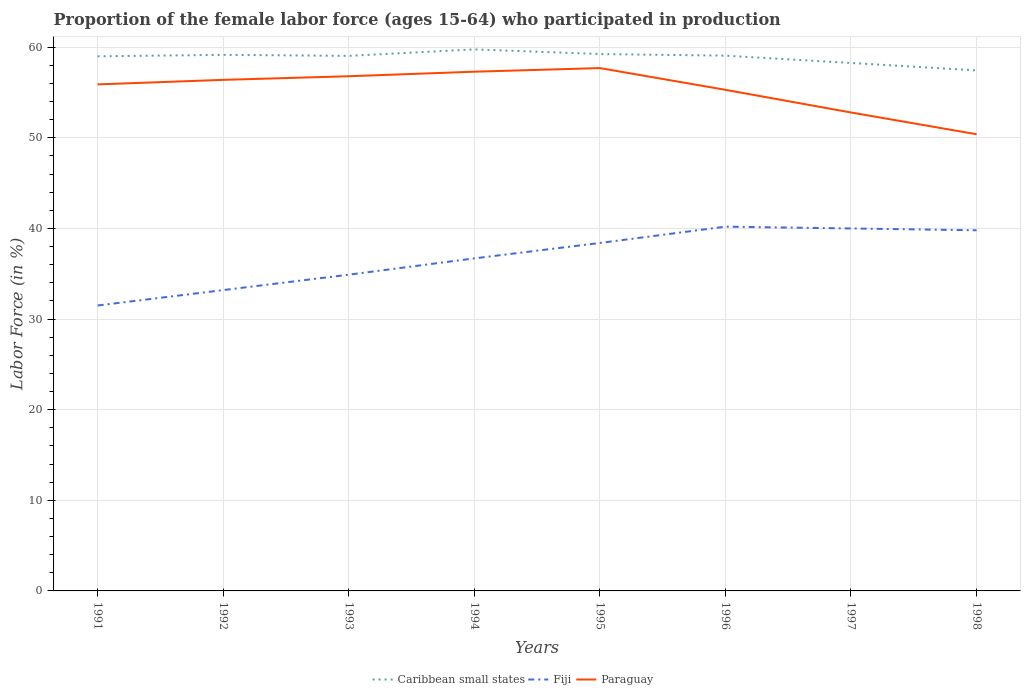Across all years, what is the maximum proportion of the female labor force who participated in production in Caribbean small states?
Your answer should be very brief. 57.44. What is the total proportion of the female labor force who participated in production in Paraguay in the graph?
Make the answer very short. 2.4. What is the difference between the highest and the second highest proportion of the female labor force who participated in production in Fiji?
Give a very brief answer. 8.7. What is the difference between the highest and the lowest proportion of the female labor force who participated in production in Fiji?
Give a very brief answer. 4. How many lines are there?
Make the answer very short. 3. What is the difference between two consecutive major ticks on the Y-axis?
Give a very brief answer. 10. Are the values on the major ticks of Y-axis written in scientific E-notation?
Offer a terse response. No. Does the graph contain any zero values?
Ensure brevity in your answer.  No. Does the graph contain grids?
Provide a short and direct response. Yes. How many legend labels are there?
Your answer should be very brief. 3. What is the title of the graph?
Make the answer very short. Proportion of the female labor force (ages 15-64) who participated in production. Does "Faeroe Islands" appear as one of the legend labels in the graph?
Your response must be concise. No. What is the label or title of the X-axis?
Give a very brief answer. Years. What is the Labor Force (in %) in Caribbean small states in 1991?
Keep it short and to the point. 59. What is the Labor Force (in %) in Fiji in 1991?
Give a very brief answer. 31.5. What is the Labor Force (in %) of Paraguay in 1991?
Offer a terse response. 55.9. What is the Labor Force (in %) of Caribbean small states in 1992?
Your response must be concise. 59.16. What is the Labor Force (in %) in Fiji in 1992?
Provide a succinct answer. 33.2. What is the Labor Force (in %) of Paraguay in 1992?
Your answer should be very brief. 56.4. What is the Labor Force (in %) of Caribbean small states in 1993?
Your response must be concise. 59.05. What is the Labor Force (in %) in Fiji in 1993?
Provide a succinct answer. 34.9. What is the Labor Force (in %) of Paraguay in 1993?
Keep it short and to the point. 56.8. What is the Labor Force (in %) in Caribbean small states in 1994?
Keep it short and to the point. 59.76. What is the Labor Force (in %) in Fiji in 1994?
Give a very brief answer. 36.7. What is the Labor Force (in %) of Paraguay in 1994?
Offer a very short reply. 57.3. What is the Labor Force (in %) of Caribbean small states in 1995?
Provide a short and direct response. 59.25. What is the Labor Force (in %) of Fiji in 1995?
Your answer should be very brief. 38.4. What is the Labor Force (in %) in Paraguay in 1995?
Give a very brief answer. 57.7. What is the Labor Force (in %) in Caribbean small states in 1996?
Ensure brevity in your answer.  59.07. What is the Labor Force (in %) in Fiji in 1996?
Your answer should be very brief. 40.2. What is the Labor Force (in %) of Paraguay in 1996?
Provide a succinct answer. 55.3. What is the Labor Force (in %) of Caribbean small states in 1997?
Make the answer very short. 58.26. What is the Labor Force (in %) in Paraguay in 1997?
Provide a short and direct response. 52.8. What is the Labor Force (in %) of Caribbean small states in 1998?
Keep it short and to the point. 57.44. What is the Labor Force (in %) in Fiji in 1998?
Your response must be concise. 39.8. What is the Labor Force (in %) of Paraguay in 1998?
Your answer should be compact. 50.4. Across all years, what is the maximum Labor Force (in %) in Caribbean small states?
Your response must be concise. 59.76. Across all years, what is the maximum Labor Force (in %) of Fiji?
Ensure brevity in your answer.  40.2. Across all years, what is the maximum Labor Force (in %) of Paraguay?
Give a very brief answer. 57.7. Across all years, what is the minimum Labor Force (in %) of Caribbean small states?
Provide a succinct answer. 57.44. Across all years, what is the minimum Labor Force (in %) in Fiji?
Provide a short and direct response. 31.5. Across all years, what is the minimum Labor Force (in %) of Paraguay?
Your answer should be compact. 50.4. What is the total Labor Force (in %) of Caribbean small states in the graph?
Offer a very short reply. 471. What is the total Labor Force (in %) in Fiji in the graph?
Offer a terse response. 294.7. What is the total Labor Force (in %) in Paraguay in the graph?
Your answer should be compact. 442.6. What is the difference between the Labor Force (in %) of Caribbean small states in 1991 and that in 1992?
Your answer should be compact. -0.16. What is the difference between the Labor Force (in %) in Fiji in 1991 and that in 1992?
Your answer should be compact. -1.7. What is the difference between the Labor Force (in %) of Paraguay in 1991 and that in 1992?
Keep it short and to the point. -0.5. What is the difference between the Labor Force (in %) in Caribbean small states in 1991 and that in 1993?
Your answer should be very brief. -0.05. What is the difference between the Labor Force (in %) in Caribbean small states in 1991 and that in 1994?
Offer a very short reply. -0.76. What is the difference between the Labor Force (in %) in Fiji in 1991 and that in 1994?
Your answer should be compact. -5.2. What is the difference between the Labor Force (in %) in Paraguay in 1991 and that in 1994?
Your answer should be compact. -1.4. What is the difference between the Labor Force (in %) in Caribbean small states in 1991 and that in 1995?
Provide a short and direct response. -0.25. What is the difference between the Labor Force (in %) in Caribbean small states in 1991 and that in 1996?
Keep it short and to the point. -0.07. What is the difference between the Labor Force (in %) of Paraguay in 1991 and that in 1996?
Provide a succinct answer. 0.6. What is the difference between the Labor Force (in %) of Caribbean small states in 1991 and that in 1997?
Provide a succinct answer. 0.74. What is the difference between the Labor Force (in %) of Fiji in 1991 and that in 1997?
Provide a succinct answer. -8.5. What is the difference between the Labor Force (in %) of Caribbean small states in 1991 and that in 1998?
Keep it short and to the point. 1.56. What is the difference between the Labor Force (in %) of Fiji in 1991 and that in 1998?
Ensure brevity in your answer.  -8.3. What is the difference between the Labor Force (in %) in Paraguay in 1991 and that in 1998?
Your response must be concise. 5.5. What is the difference between the Labor Force (in %) of Caribbean small states in 1992 and that in 1993?
Keep it short and to the point. 0.11. What is the difference between the Labor Force (in %) in Paraguay in 1992 and that in 1993?
Your answer should be very brief. -0.4. What is the difference between the Labor Force (in %) in Caribbean small states in 1992 and that in 1994?
Keep it short and to the point. -0.6. What is the difference between the Labor Force (in %) of Fiji in 1992 and that in 1994?
Offer a very short reply. -3.5. What is the difference between the Labor Force (in %) of Paraguay in 1992 and that in 1994?
Ensure brevity in your answer.  -0.9. What is the difference between the Labor Force (in %) of Caribbean small states in 1992 and that in 1995?
Your response must be concise. -0.09. What is the difference between the Labor Force (in %) in Caribbean small states in 1992 and that in 1996?
Give a very brief answer. 0.09. What is the difference between the Labor Force (in %) in Fiji in 1992 and that in 1996?
Keep it short and to the point. -7. What is the difference between the Labor Force (in %) of Caribbean small states in 1992 and that in 1997?
Offer a terse response. 0.9. What is the difference between the Labor Force (in %) in Fiji in 1992 and that in 1997?
Ensure brevity in your answer.  -6.8. What is the difference between the Labor Force (in %) in Paraguay in 1992 and that in 1997?
Your answer should be compact. 3.6. What is the difference between the Labor Force (in %) of Caribbean small states in 1992 and that in 1998?
Provide a succinct answer. 1.72. What is the difference between the Labor Force (in %) in Caribbean small states in 1993 and that in 1994?
Your answer should be very brief. -0.72. What is the difference between the Labor Force (in %) of Paraguay in 1993 and that in 1994?
Offer a very short reply. -0.5. What is the difference between the Labor Force (in %) in Caribbean small states in 1993 and that in 1995?
Give a very brief answer. -0.2. What is the difference between the Labor Force (in %) in Fiji in 1993 and that in 1995?
Provide a succinct answer. -3.5. What is the difference between the Labor Force (in %) in Caribbean small states in 1993 and that in 1996?
Your response must be concise. -0.02. What is the difference between the Labor Force (in %) in Fiji in 1993 and that in 1996?
Make the answer very short. -5.3. What is the difference between the Labor Force (in %) of Caribbean small states in 1993 and that in 1997?
Make the answer very short. 0.78. What is the difference between the Labor Force (in %) of Fiji in 1993 and that in 1997?
Make the answer very short. -5.1. What is the difference between the Labor Force (in %) of Paraguay in 1993 and that in 1997?
Your answer should be compact. 4. What is the difference between the Labor Force (in %) in Caribbean small states in 1993 and that in 1998?
Offer a very short reply. 1.61. What is the difference between the Labor Force (in %) of Fiji in 1993 and that in 1998?
Your answer should be compact. -4.9. What is the difference between the Labor Force (in %) of Caribbean small states in 1994 and that in 1995?
Keep it short and to the point. 0.51. What is the difference between the Labor Force (in %) of Fiji in 1994 and that in 1995?
Your answer should be very brief. -1.7. What is the difference between the Labor Force (in %) in Paraguay in 1994 and that in 1995?
Ensure brevity in your answer.  -0.4. What is the difference between the Labor Force (in %) in Caribbean small states in 1994 and that in 1996?
Offer a terse response. 0.69. What is the difference between the Labor Force (in %) of Caribbean small states in 1994 and that in 1997?
Ensure brevity in your answer.  1.5. What is the difference between the Labor Force (in %) of Paraguay in 1994 and that in 1997?
Give a very brief answer. 4.5. What is the difference between the Labor Force (in %) of Caribbean small states in 1994 and that in 1998?
Your answer should be compact. 2.32. What is the difference between the Labor Force (in %) in Fiji in 1994 and that in 1998?
Your response must be concise. -3.1. What is the difference between the Labor Force (in %) of Caribbean small states in 1995 and that in 1996?
Provide a short and direct response. 0.18. What is the difference between the Labor Force (in %) in Fiji in 1995 and that in 1996?
Offer a terse response. -1.8. What is the difference between the Labor Force (in %) in Paraguay in 1995 and that in 1996?
Offer a very short reply. 2.4. What is the difference between the Labor Force (in %) in Caribbean small states in 1995 and that in 1997?
Give a very brief answer. 0.99. What is the difference between the Labor Force (in %) in Paraguay in 1995 and that in 1997?
Keep it short and to the point. 4.9. What is the difference between the Labor Force (in %) of Caribbean small states in 1995 and that in 1998?
Your answer should be very brief. 1.81. What is the difference between the Labor Force (in %) of Fiji in 1995 and that in 1998?
Provide a succinct answer. -1.4. What is the difference between the Labor Force (in %) in Caribbean small states in 1996 and that in 1997?
Your response must be concise. 0.81. What is the difference between the Labor Force (in %) in Fiji in 1996 and that in 1997?
Provide a succinct answer. 0.2. What is the difference between the Labor Force (in %) of Paraguay in 1996 and that in 1997?
Your answer should be compact. 2.5. What is the difference between the Labor Force (in %) in Caribbean small states in 1996 and that in 1998?
Ensure brevity in your answer.  1.63. What is the difference between the Labor Force (in %) of Fiji in 1996 and that in 1998?
Offer a very short reply. 0.4. What is the difference between the Labor Force (in %) in Caribbean small states in 1997 and that in 1998?
Give a very brief answer. 0.82. What is the difference between the Labor Force (in %) of Caribbean small states in 1991 and the Labor Force (in %) of Fiji in 1992?
Give a very brief answer. 25.8. What is the difference between the Labor Force (in %) of Caribbean small states in 1991 and the Labor Force (in %) of Paraguay in 1992?
Offer a very short reply. 2.6. What is the difference between the Labor Force (in %) of Fiji in 1991 and the Labor Force (in %) of Paraguay in 1992?
Offer a very short reply. -24.9. What is the difference between the Labor Force (in %) in Caribbean small states in 1991 and the Labor Force (in %) in Fiji in 1993?
Provide a short and direct response. 24.1. What is the difference between the Labor Force (in %) in Caribbean small states in 1991 and the Labor Force (in %) in Paraguay in 1993?
Ensure brevity in your answer.  2.2. What is the difference between the Labor Force (in %) in Fiji in 1991 and the Labor Force (in %) in Paraguay in 1993?
Your response must be concise. -25.3. What is the difference between the Labor Force (in %) in Caribbean small states in 1991 and the Labor Force (in %) in Fiji in 1994?
Ensure brevity in your answer.  22.3. What is the difference between the Labor Force (in %) in Caribbean small states in 1991 and the Labor Force (in %) in Paraguay in 1994?
Your response must be concise. 1.7. What is the difference between the Labor Force (in %) in Fiji in 1991 and the Labor Force (in %) in Paraguay in 1994?
Offer a terse response. -25.8. What is the difference between the Labor Force (in %) in Caribbean small states in 1991 and the Labor Force (in %) in Fiji in 1995?
Offer a very short reply. 20.6. What is the difference between the Labor Force (in %) of Caribbean small states in 1991 and the Labor Force (in %) of Paraguay in 1995?
Give a very brief answer. 1.3. What is the difference between the Labor Force (in %) of Fiji in 1991 and the Labor Force (in %) of Paraguay in 1995?
Provide a short and direct response. -26.2. What is the difference between the Labor Force (in %) of Caribbean small states in 1991 and the Labor Force (in %) of Fiji in 1996?
Your response must be concise. 18.8. What is the difference between the Labor Force (in %) in Caribbean small states in 1991 and the Labor Force (in %) in Paraguay in 1996?
Provide a short and direct response. 3.7. What is the difference between the Labor Force (in %) of Fiji in 1991 and the Labor Force (in %) of Paraguay in 1996?
Give a very brief answer. -23.8. What is the difference between the Labor Force (in %) in Caribbean small states in 1991 and the Labor Force (in %) in Fiji in 1997?
Give a very brief answer. 19. What is the difference between the Labor Force (in %) in Caribbean small states in 1991 and the Labor Force (in %) in Paraguay in 1997?
Provide a short and direct response. 6.2. What is the difference between the Labor Force (in %) of Fiji in 1991 and the Labor Force (in %) of Paraguay in 1997?
Offer a terse response. -21.3. What is the difference between the Labor Force (in %) of Caribbean small states in 1991 and the Labor Force (in %) of Fiji in 1998?
Provide a short and direct response. 19.2. What is the difference between the Labor Force (in %) in Caribbean small states in 1991 and the Labor Force (in %) in Paraguay in 1998?
Keep it short and to the point. 8.6. What is the difference between the Labor Force (in %) in Fiji in 1991 and the Labor Force (in %) in Paraguay in 1998?
Offer a very short reply. -18.9. What is the difference between the Labor Force (in %) of Caribbean small states in 1992 and the Labor Force (in %) of Fiji in 1993?
Your answer should be very brief. 24.26. What is the difference between the Labor Force (in %) in Caribbean small states in 1992 and the Labor Force (in %) in Paraguay in 1993?
Make the answer very short. 2.36. What is the difference between the Labor Force (in %) in Fiji in 1992 and the Labor Force (in %) in Paraguay in 1993?
Your answer should be very brief. -23.6. What is the difference between the Labor Force (in %) of Caribbean small states in 1992 and the Labor Force (in %) of Fiji in 1994?
Make the answer very short. 22.46. What is the difference between the Labor Force (in %) in Caribbean small states in 1992 and the Labor Force (in %) in Paraguay in 1994?
Provide a succinct answer. 1.86. What is the difference between the Labor Force (in %) of Fiji in 1992 and the Labor Force (in %) of Paraguay in 1994?
Provide a succinct answer. -24.1. What is the difference between the Labor Force (in %) in Caribbean small states in 1992 and the Labor Force (in %) in Fiji in 1995?
Provide a succinct answer. 20.76. What is the difference between the Labor Force (in %) of Caribbean small states in 1992 and the Labor Force (in %) of Paraguay in 1995?
Your response must be concise. 1.46. What is the difference between the Labor Force (in %) of Fiji in 1992 and the Labor Force (in %) of Paraguay in 1995?
Offer a very short reply. -24.5. What is the difference between the Labor Force (in %) of Caribbean small states in 1992 and the Labor Force (in %) of Fiji in 1996?
Your answer should be very brief. 18.96. What is the difference between the Labor Force (in %) of Caribbean small states in 1992 and the Labor Force (in %) of Paraguay in 1996?
Your answer should be compact. 3.86. What is the difference between the Labor Force (in %) of Fiji in 1992 and the Labor Force (in %) of Paraguay in 1996?
Offer a very short reply. -22.1. What is the difference between the Labor Force (in %) of Caribbean small states in 1992 and the Labor Force (in %) of Fiji in 1997?
Offer a very short reply. 19.16. What is the difference between the Labor Force (in %) in Caribbean small states in 1992 and the Labor Force (in %) in Paraguay in 1997?
Provide a short and direct response. 6.36. What is the difference between the Labor Force (in %) in Fiji in 1992 and the Labor Force (in %) in Paraguay in 1997?
Offer a terse response. -19.6. What is the difference between the Labor Force (in %) in Caribbean small states in 1992 and the Labor Force (in %) in Fiji in 1998?
Your answer should be very brief. 19.36. What is the difference between the Labor Force (in %) in Caribbean small states in 1992 and the Labor Force (in %) in Paraguay in 1998?
Your answer should be very brief. 8.76. What is the difference between the Labor Force (in %) in Fiji in 1992 and the Labor Force (in %) in Paraguay in 1998?
Your answer should be very brief. -17.2. What is the difference between the Labor Force (in %) in Caribbean small states in 1993 and the Labor Force (in %) in Fiji in 1994?
Your response must be concise. 22.35. What is the difference between the Labor Force (in %) of Caribbean small states in 1993 and the Labor Force (in %) of Paraguay in 1994?
Keep it short and to the point. 1.75. What is the difference between the Labor Force (in %) in Fiji in 1993 and the Labor Force (in %) in Paraguay in 1994?
Ensure brevity in your answer.  -22.4. What is the difference between the Labor Force (in %) of Caribbean small states in 1993 and the Labor Force (in %) of Fiji in 1995?
Offer a terse response. 20.65. What is the difference between the Labor Force (in %) of Caribbean small states in 1993 and the Labor Force (in %) of Paraguay in 1995?
Offer a very short reply. 1.35. What is the difference between the Labor Force (in %) of Fiji in 1993 and the Labor Force (in %) of Paraguay in 1995?
Your answer should be compact. -22.8. What is the difference between the Labor Force (in %) of Caribbean small states in 1993 and the Labor Force (in %) of Fiji in 1996?
Your answer should be very brief. 18.85. What is the difference between the Labor Force (in %) of Caribbean small states in 1993 and the Labor Force (in %) of Paraguay in 1996?
Your answer should be compact. 3.75. What is the difference between the Labor Force (in %) of Fiji in 1993 and the Labor Force (in %) of Paraguay in 1996?
Give a very brief answer. -20.4. What is the difference between the Labor Force (in %) of Caribbean small states in 1993 and the Labor Force (in %) of Fiji in 1997?
Offer a terse response. 19.05. What is the difference between the Labor Force (in %) in Caribbean small states in 1993 and the Labor Force (in %) in Paraguay in 1997?
Give a very brief answer. 6.25. What is the difference between the Labor Force (in %) in Fiji in 1993 and the Labor Force (in %) in Paraguay in 1997?
Provide a succinct answer. -17.9. What is the difference between the Labor Force (in %) of Caribbean small states in 1993 and the Labor Force (in %) of Fiji in 1998?
Make the answer very short. 19.25. What is the difference between the Labor Force (in %) in Caribbean small states in 1993 and the Labor Force (in %) in Paraguay in 1998?
Your answer should be compact. 8.65. What is the difference between the Labor Force (in %) in Fiji in 1993 and the Labor Force (in %) in Paraguay in 1998?
Make the answer very short. -15.5. What is the difference between the Labor Force (in %) of Caribbean small states in 1994 and the Labor Force (in %) of Fiji in 1995?
Ensure brevity in your answer.  21.36. What is the difference between the Labor Force (in %) in Caribbean small states in 1994 and the Labor Force (in %) in Paraguay in 1995?
Ensure brevity in your answer.  2.06. What is the difference between the Labor Force (in %) in Fiji in 1994 and the Labor Force (in %) in Paraguay in 1995?
Provide a short and direct response. -21. What is the difference between the Labor Force (in %) in Caribbean small states in 1994 and the Labor Force (in %) in Fiji in 1996?
Your answer should be compact. 19.56. What is the difference between the Labor Force (in %) in Caribbean small states in 1994 and the Labor Force (in %) in Paraguay in 1996?
Provide a succinct answer. 4.46. What is the difference between the Labor Force (in %) of Fiji in 1994 and the Labor Force (in %) of Paraguay in 1996?
Offer a very short reply. -18.6. What is the difference between the Labor Force (in %) of Caribbean small states in 1994 and the Labor Force (in %) of Fiji in 1997?
Give a very brief answer. 19.76. What is the difference between the Labor Force (in %) in Caribbean small states in 1994 and the Labor Force (in %) in Paraguay in 1997?
Offer a very short reply. 6.96. What is the difference between the Labor Force (in %) of Fiji in 1994 and the Labor Force (in %) of Paraguay in 1997?
Your response must be concise. -16.1. What is the difference between the Labor Force (in %) of Caribbean small states in 1994 and the Labor Force (in %) of Fiji in 1998?
Offer a very short reply. 19.96. What is the difference between the Labor Force (in %) in Caribbean small states in 1994 and the Labor Force (in %) in Paraguay in 1998?
Keep it short and to the point. 9.36. What is the difference between the Labor Force (in %) of Fiji in 1994 and the Labor Force (in %) of Paraguay in 1998?
Give a very brief answer. -13.7. What is the difference between the Labor Force (in %) in Caribbean small states in 1995 and the Labor Force (in %) in Fiji in 1996?
Give a very brief answer. 19.05. What is the difference between the Labor Force (in %) in Caribbean small states in 1995 and the Labor Force (in %) in Paraguay in 1996?
Offer a terse response. 3.95. What is the difference between the Labor Force (in %) in Fiji in 1995 and the Labor Force (in %) in Paraguay in 1996?
Your answer should be very brief. -16.9. What is the difference between the Labor Force (in %) in Caribbean small states in 1995 and the Labor Force (in %) in Fiji in 1997?
Your answer should be compact. 19.25. What is the difference between the Labor Force (in %) of Caribbean small states in 1995 and the Labor Force (in %) of Paraguay in 1997?
Your answer should be very brief. 6.45. What is the difference between the Labor Force (in %) in Fiji in 1995 and the Labor Force (in %) in Paraguay in 1997?
Offer a terse response. -14.4. What is the difference between the Labor Force (in %) in Caribbean small states in 1995 and the Labor Force (in %) in Fiji in 1998?
Keep it short and to the point. 19.45. What is the difference between the Labor Force (in %) in Caribbean small states in 1995 and the Labor Force (in %) in Paraguay in 1998?
Give a very brief answer. 8.85. What is the difference between the Labor Force (in %) of Caribbean small states in 1996 and the Labor Force (in %) of Fiji in 1997?
Make the answer very short. 19.07. What is the difference between the Labor Force (in %) in Caribbean small states in 1996 and the Labor Force (in %) in Paraguay in 1997?
Your response must be concise. 6.27. What is the difference between the Labor Force (in %) in Fiji in 1996 and the Labor Force (in %) in Paraguay in 1997?
Your answer should be compact. -12.6. What is the difference between the Labor Force (in %) in Caribbean small states in 1996 and the Labor Force (in %) in Fiji in 1998?
Keep it short and to the point. 19.27. What is the difference between the Labor Force (in %) of Caribbean small states in 1996 and the Labor Force (in %) of Paraguay in 1998?
Your answer should be compact. 8.67. What is the difference between the Labor Force (in %) in Caribbean small states in 1997 and the Labor Force (in %) in Fiji in 1998?
Your answer should be compact. 18.46. What is the difference between the Labor Force (in %) of Caribbean small states in 1997 and the Labor Force (in %) of Paraguay in 1998?
Your response must be concise. 7.86. What is the average Labor Force (in %) in Caribbean small states per year?
Give a very brief answer. 58.87. What is the average Labor Force (in %) in Fiji per year?
Ensure brevity in your answer.  36.84. What is the average Labor Force (in %) of Paraguay per year?
Provide a short and direct response. 55.33. In the year 1991, what is the difference between the Labor Force (in %) of Caribbean small states and Labor Force (in %) of Fiji?
Offer a very short reply. 27.5. In the year 1991, what is the difference between the Labor Force (in %) in Caribbean small states and Labor Force (in %) in Paraguay?
Ensure brevity in your answer.  3.1. In the year 1991, what is the difference between the Labor Force (in %) of Fiji and Labor Force (in %) of Paraguay?
Your response must be concise. -24.4. In the year 1992, what is the difference between the Labor Force (in %) in Caribbean small states and Labor Force (in %) in Fiji?
Keep it short and to the point. 25.96. In the year 1992, what is the difference between the Labor Force (in %) in Caribbean small states and Labor Force (in %) in Paraguay?
Offer a very short reply. 2.76. In the year 1992, what is the difference between the Labor Force (in %) in Fiji and Labor Force (in %) in Paraguay?
Provide a short and direct response. -23.2. In the year 1993, what is the difference between the Labor Force (in %) in Caribbean small states and Labor Force (in %) in Fiji?
Keep it short and to the point. 24.15. In the year 1993, what is the difference between the Labor Force (in %) in Caribbean small states and Labor Force (in %) in Paraguay?
Your answer should be compact. 2.25. In the year 1993, what is the difference between the Labor Force (in %) in Fiji and Labor Force (in %) in Paraguay?
Your answer should be very brief. -21.9. In the year 1994, what is the difference between the Labor Force (in %) of Caribbean small states and Labor Force (in %) of Fiji?
Your answer should be compact. 23.06. In the year 1994, what is the difference between the Labor Force (in %) in Caribbean small states and Labor Force (in %) in Paraguay?
Offer a terse response. 2.46. In the year 1994, what is the difference between the Labor Force (in %) in Fiji and Labor Force (in %) in Paraguay?
Offer a very short reply. -20.6. In the year 1995, what is the difference between the Labor Force (in %) of Caribbean small states and Labor Force (in %) of Fiji?
Give a very brief answer. 20.85. In the year 1995, what is the difference between the Labor Force (in %) in Caribbean small states and Labor Force (in %) in Paraguay?
Keep it short and to the point. 1.55. In the year 1995, what is the difference between the Labor Force (in %) in Fiji and Labor Force (in %) in Paraguay?
Provide a short and direct response. -19.3. In the year 1996, what is the difference between the Labor Force (in %) of Caribbean small states and Labor Force (in %) of Fiji?
Your answer should be compact. 18.87. In the year 1996, what is the difference between the Labor Force (in %) in Caribbean small states and Labor Force (in %) in Paraguay?
Make the answer very short. 3.77. In the year 1996, what is the difference between the Labor Force (in %) in Fiji and Labor Force (in %) in Paraguay?
Your answer should be very brief. -15.1. In the year 1997, what is the difference between the Labor Force (in %) of Caribbean small states and Labor Force (in %) of Fiji?
Keep it short and to the point. 18.26. In the year 1997, what is the difference between the Labor Force (in %) in Caribbean small states and Labor Force (in %) in Paraguay?
Provide a succinct answer. 5.46. In the year 1997, what is the difference between the Labor Force (in %) of Fiji and Labor Force (in %) of Paraguay?
Make the answer very short. -12.8. In the year 1998, what is the difference between the Labor Force (in %) in Caribbean small states and Labor Force (in %) in Fiji?
Offer a terse response. 17.64. In the year 1998, what is the difference between the Labor Force (in %) in Caribbean small states and Labor Force (in %) in Paraguay?
Your answer should be compact. 7.04. In the year 1998, what is the difference between the Labor Force (in %) in Fiji and Labor Force (in %) in Paraguay?
Provide a succinct answer. -10.6. What is the ratio of the Labor Force (in %) of Caribbean small states in 1991 to that in 1992?
Offer a terse response. 1. What is the ratio of the Labor Force (in %) of Fiji in 1991 to that in 1992?
Give a very brief answer. 0.95. What is the ratio of the Labor Force (in %) of Paraguay in 1991 to that in 1992?
Your answer should be very brief. 0.99. What is the ratio of the Labor Force (in %) in Fiji in 1991 to that in 1993?
Provide a succinct answer. 0.9. What is the ratio of the Labor Force (in %) of Paraguay in 1991 to that in 1993?
Offer a terse response. 0.98. What is the ratio of the Labor Force (in %) of Caribbean small states in 1991 to that in 1994?
Keep it short and to the point. 0.99. What is the ratio of the Labor Force (in %) in Fiji in 1991 to that in 1994?
Your response must be concise. 0.86. What is the ratio of the Labor Force (in %) in Paraguay in 1991 to that in 1994?
Give a very brief answer. 0.98. What is the ratio of the Labor Force (in %) of Fiji in 1991 to that in 1995?
Offer a very short reply. 0.82. What is the ratio of the Labor Force (in %) of Paraguay in 1991 to that in 1995?
Keep it short and to the point. 0.97. What is the ratio of the Labor Force (in %) of Fiji in 1991 to that in 1996?
Your response must be concise. 0.78. What is the ratio of the Labor Force (in %) of Paraguay in 1991 to that in 1996?
Your answer should be compact. 1.01. What is the ratio of the Labor Force (in %) in Caribbean small states in 1991 to that in 1997?
Your answer should be very brief. 1.01. What is the ratio of the Labor Force (in %) of Fiji in 1991 to that in 1997?
Make the answer very short. 0.79. What is the ratio of the Labor Force (in %) of Paraguay in 1991 to that in 1997?
Make the answer very short. 1.06. What is the ratio of the Labor Force (in %) in Caribbean small states in 1991 to that in 1998?
Make the answer very short. 1.03. What is the ratio of the Labor Force (in %) in Fiji in 1991 to that in 1998?
Ensure brevity in your answer.  0.79. What is the ratio of the Labor Force (in %) of Paraguay in 1991 to that in 1998?
Provide a short and direct response. 1.11. What is the ratio of the Labor Force (in %) of Caribbean small states in 1992 to that in 1993?
Give a very brief answer. 1. What is the ratio of the Labor Force (in %) of Fiji in 1992 to that in 1993?
Make the answer very short. 0.95. What is the ratio of the Labor Force (in %) in Fiji in 1992 to that in 1994?
Your answer should be compact. 0.9. What is the ratio of the Labor Force (in %) in Paraguay in 1992 to that in 1994?
Your answer should be very brief. 0.98. What is the ratio of the Labor Force (in %) of Fiji in 1992 to that in 1995?
Ensure brevity in your answer.  0.86. What is the ratio of the Labor Force (in %) of Paraguay in 1992 to that in 1995?
Offer a very short reply. 0.98. What is the ratio of the Labor Force (in %) of Caribbean small states in 1992 to that in 1996?
Your answer should be compact. 1. What is the ratio of the Labor Force (in %) of Fiji in 1992 to that in 1996?
Offer a very short reply. 0.83. What is the ratio of the Labor Force (in %) in Paraguay in 1992 to that in 1996?
Ensure brevity in your answer.  1.02. What is the ratio of the Labor Force (in %) of Caribbean small states in 1992 to that in 1997?
Give a very brief answer. 1.02. What is the ratio of the Labor Force (in %) of Fiji in 1992 to that in 1997?
Provide a short and direct response. 0.83. What is the ratio of the Labor Force (in %) in Paraguay in 1992 to that in 1997?
Make the answer very short. 1.07. What is the ratio of the Labor Force (in %) in Caribbean small states in 1992 to that in 1998?
Ensure brevity in your answer.  1.03. What is the ratio of the Labor Force (in %) in Fiji in 1992 to that in 1998?
Offer a terse response. 0.83. What is the ratio of the Labor Force (in %) of Paraguay in 1992 to that in 1998?
Your response must be concise. 1.12. What is the ratio of the Labor Force (in %) of Caribbean small states in 1993 to that in 1994?
Make the answer very short. 0.99. What is the ratio of the Labor Force (in %) of Fiji in 1993 to that in 1994?
Your answer should be compact. 0.95. What is the ratio of the Labor Force (in %) in Paraguay in 1993 to that in 1994?
Keep it short and to the point. 0.99. What is the ratio of the Labor Force (in %) of Caribbean small states in 1993 to that in 1995?
Your response must be concise. 1. What is the ratio of the Labor Force (in %) of Fiji in 1993 to that in 1995?
Ensure brevity in your answer.  0.91. What is the ratio of the Labor Force (in %) of Paraguay in 1993 to that in 1995?
Ensure brevity in your answer.  0.98. What is the ratio of the Labor Force (in %) of Caribbean small states in 1993 to that in 1996?
Provide a succinct answer. 1. What is the ratio of the Labor Force (in %) in Fiji in 1993 to that in 1996?
Your answer should be compact. 0.87. What is the ratio of the Labor Force (in %) in Paraguay in 1993 to that in 1996?
Your answer should be compact. 1.03. What is the ratio of the Labor Force (in %) of Caribbean small states in 1993 to that in 1997?
Provide a succinct answer. 1.01. What is the ratio of the Labor Force (in %) in Fiji in 1993 to that in 1997?
Your answer should be very brief. 0.87. What is the ratio of the Labor Force (in %) in Paraguay in 1993 to that in 1997?
Offer a terse response. 1.08. What is the ratio of the Labor Force (in %) of Caribbean small states in 1993 to that in 1998?
Keep it short and to the point. 1.03. What is the ratio of the Labor Force (in %) in Fiji in 1993 to that in 1998?
Offer a very short reply. 0.88. What is the ratio of the Labor Force (in %) of Paraguay in 1993 to that in 1998?
Ensure brevity in your answer.  1.13. What is the ratio of the Labor Force (in %) in Caribbean small states in 1994 to that in 1995?
Ensure brevity in your answer.  1.01. What is the ratio of the Labor Force (in %) of Fiji in 1994 to that in 1995?
Your response must be concise. 0.96. What is the ratio of the Labor Force (in %) of Paraguay in 1994 to that in 1995?
Your answer should be compact. 0.99. What is the ratio of the Labor Force (in %) in Caribbean small states in 1994 to that in 1996?
Offer a very short reply. 1.01. What is the ratio of the Labor Force (in %) of Fiji in 1994 to that in 1996?
Provide a succinct answer. 0.91. What is the ratio of the Labor Force (in %) in Paraguay in 1994 to that in 1996?
Ensure brevity in your answer.  1.04. What is the ratio of the Labor Force (in %) in Caribbean small states in 1994 to that in 1997?
Keep it short and to the point. 1.03. What is the ratio of the Labor Force (in %) of Fiji in 1994 to that in 1997?
Your answer should be compact. 0.92. What is the ratio of the Labor Force (in %) in Paraguay in 1994 to that in 1997?
Provide a succinct answer. 1.09. What is the ratio of the Labor Force (in %) in Caribbean small states in 1994 to that in 1998?
Your answer should be very brief. 1.04. What is the ratio of the Labor Force (in %) in Fiji in 1994 to that in 1998?
Provide a succinct answer. 0.92. What is the ratio of the Labor Force (in %) in Paraguay in 1994 to that in 1998?
Provide a succinct answer. 1.14. What is the ratio of the Labor Force (in %) of Fiji in 1995 to that in 1996?
Your response must be concise. 0.96. What is the ratio of the Labor Force (in %) of Paraguay in 1995 to that in 1996?
Keep it short and to the point. 1.04. What is the ratio of the Labor Force (in %) in Caribbean small states in 1995 to that in 1997?
Offer a terse response. 1.02. What is the ratio of the Labor Force (in %) in Fiji in 1995 to that in 1997?
Provide a succinct answer. 0.96. What is the ratio of the Labor Force (in %) of Paraguay in 1995 to that in 1997?
Offer a very short reply. 1.09. What is the ratio of the Labor Force (in %) of Caribbean small states in 1995 to that in 1998?
Your response must be concise. 1.03. What is the ratio of the Labor Force (in %) of Fiji in 1995 to that in 1998?
Offer a very short reply. 0.96. What is the ratio of the Labor Force (in %) of Paraguay in 1995 to that in 1998?
Your answer should be very brief. 1.14. What is the ratio of the Labor Force (in %) in Caribbean small states in 1996 to that in 1997?
Offer a terse response. 1.01. What is the ratio of the Labor Force (in %) in Paraguay in 1996 to that in 1997?
Offer a very short reply. 1.05. What is the ratio of the Labor Force (in %) of Caribbean small states in 1996 to that in 1998?
Keep it short and to the point. 1.03. What is the ratio of the Labor Force (in %) in Fiji in 1996 to that in 1998?
Make the answer very short. 1.01. What is the ratio of the Labor Force (in %) in Paraguay in 1996 to that in 1998?
Offer a very short reply. 1.1. What is the ratio of the Labor Force (in %) of Caribbean small states in 1997 to that in 1998?
Offer a terse response. 1.01. What is the ratio of the Labor Force (in %) of Paraguay in 1997 to that in 1998?
Ensure brevity in your answer.  1.05. What is the difference between the highest and the second highest Labor Force (in %) in Caribbean small states?
Offer a terse response. 0.51. What is the difference between the highest and the second highest Labor Force (in %) of Paraguay?
Make the answer very short. 0.4. What is the difference between the highest and the lowest Labor Force (in %) of Caribbean small states?
Provide a succinct answer. 2.32. What is the difference between the highest and the lowest Labor Force (in %) in Paraguay?
Ensure brevity in your answer.  7.3. 